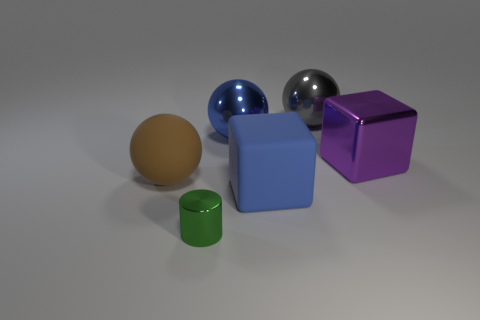Subtract all metallic balls. How many balls are left? 1 Add 3 tiny green shiny objects. How many objects exist? 9 Subtract all brown spheres. How many spheres are left? 2 Subtract all cylinders. How many objects are left? 5 Subtract all matte objects. Subtract all large green matte cylinders. How many objects are left? 4 Add 6 large purple blocks. How many large purple blocks are left? 7 Add 5 tiny cylinders. How many tiny cylinders exist? 6 Subtract 0 purple cylinders. How many objects are left? 6 Subtract all gray balls. Subtract all gray cylinders. How many balls are left? 2 